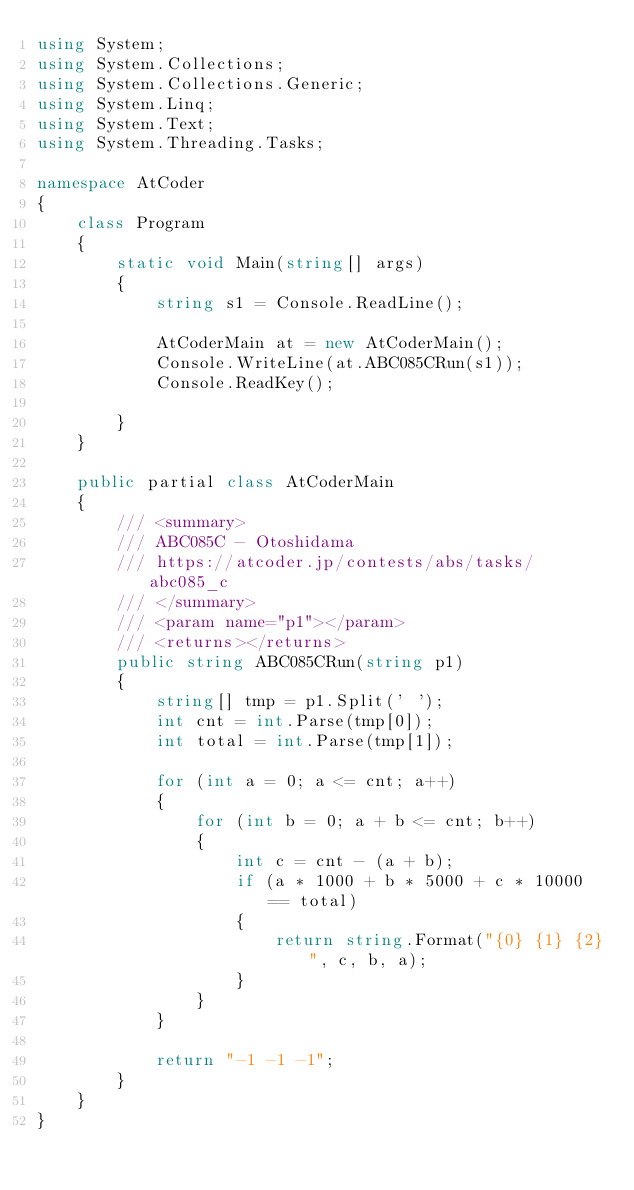Convert code to text. <code><loc_0><loc_0><loc_500><loc_500><_C#_>using System;
using System.Collections;
using System.Collections.Generic;
using System.Linq;
using System.Text;
using System.Threading.Tasks;

namespace AtCoder
{
    class Program
    {
        static void Main(string[] args)
        {
            string s1 = Console.ReadLine();

            AtCoderMain at = new AtCoderMain();
            Console.WriteLine(at.ABC085CRun(s1));
            Console.ReadKey();

        }
    }

    public partial class AtCoderMain
    {
        /// <summary>
        /// ABC085C - Otoshidama
        /// https://atcoder.jp/contests/abs/tasks/abc085_c
        /// </summary>
        /// <param name="p1"></param>
        /// <returns></returns>
        public string ABC085CRun(string p1)
        {
            string[] tmp = p1.Split(' ');
            int cnt = int.Parse(tmp[0]);
            int total = int.Parse(tmp[1]);

            for (int a = 0; a <= cnt; a++)
            {
                for (int b = 0; a + b <= cnt; b++)
                {
                    int c = cnt - (a + b);
                    if (a * 1000 + b * 5000 + c * 10000 == total)
                    {
                        return string.Format("{0} {1} {2}", c, b, a);
                    }
                }
            }

            return "-1 -1 -1";
        }
    }
}
</code> 